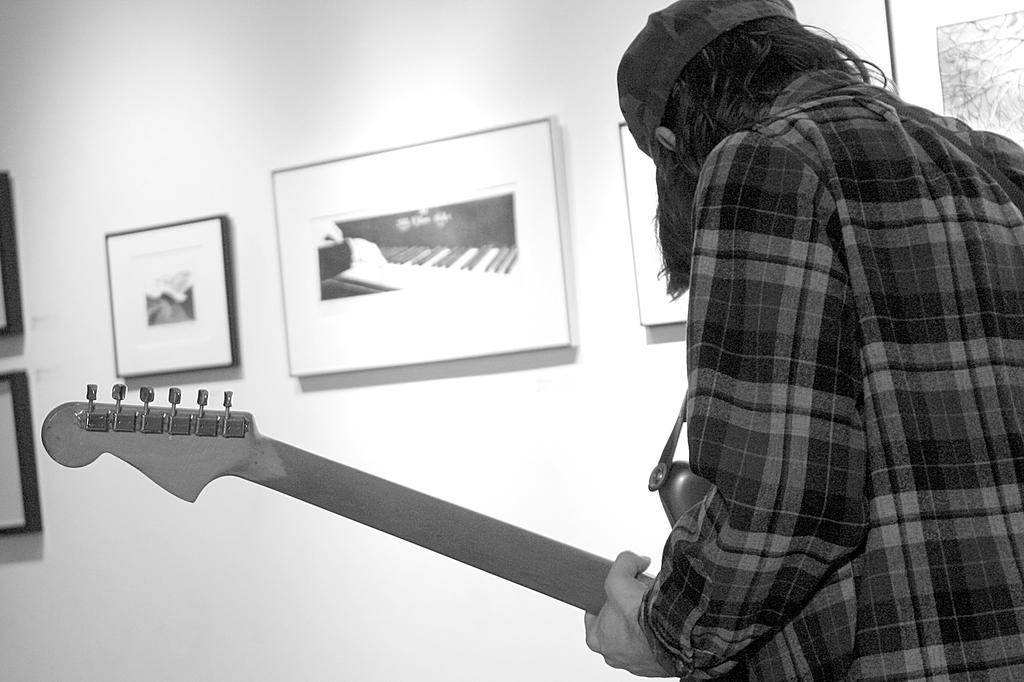What is the main subject of the image? There is a person in the image. What is the person holding in his hand? The person is holding a guitar in his hand. What can be seen in the background of the image? There are photo frames visible in the background of the image. What type of wren can be seen perched on the guitar in the image? There is no wren present in the image; the person is holding a guitar, but there are no birds visible. 